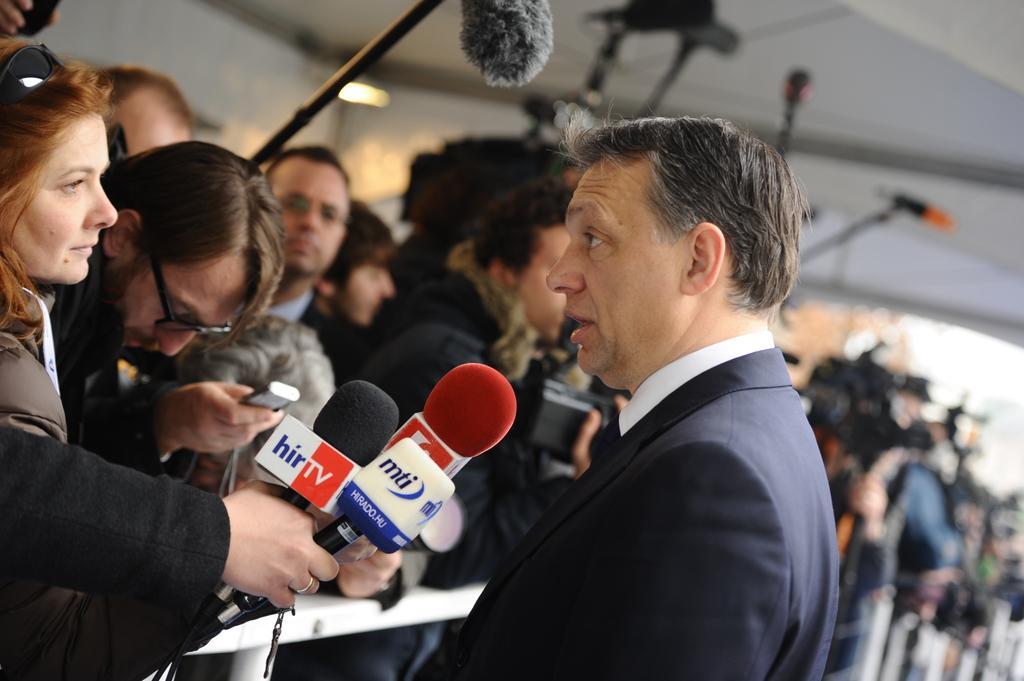How would you summarize this image in a sentence or two? This picture shows a man speaking and few people standing and holding microphones and we see few are holding cameras in their hand 